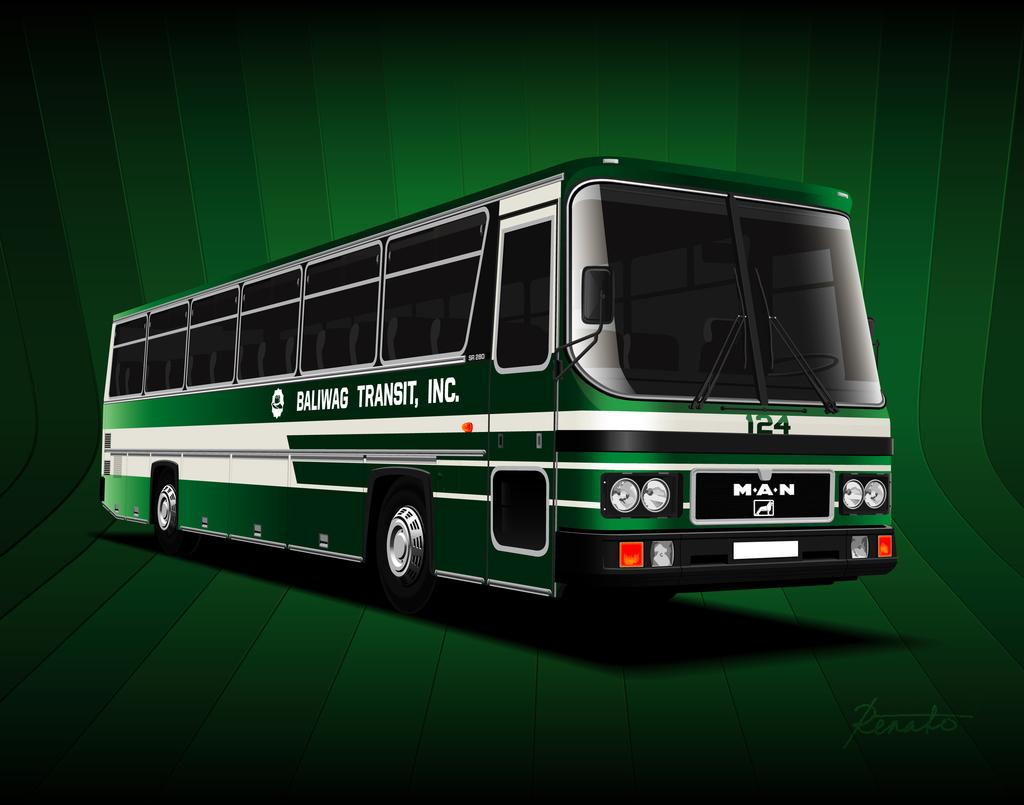What is the main subject of the image? The main subject of the image is a bus. What can be seen in the background of the image? The background of the image is green. Is there any additional information or marking on the image? Yes, there is a watermark at the bottom right corner of the image. How many tents are set up near the bus in the image? There are no tents present in the image; it only features a bus and a green background. What type of fly can be seen buzzing around the bus in the image? There are no flies present in the image; it only features a bus and a green background. 